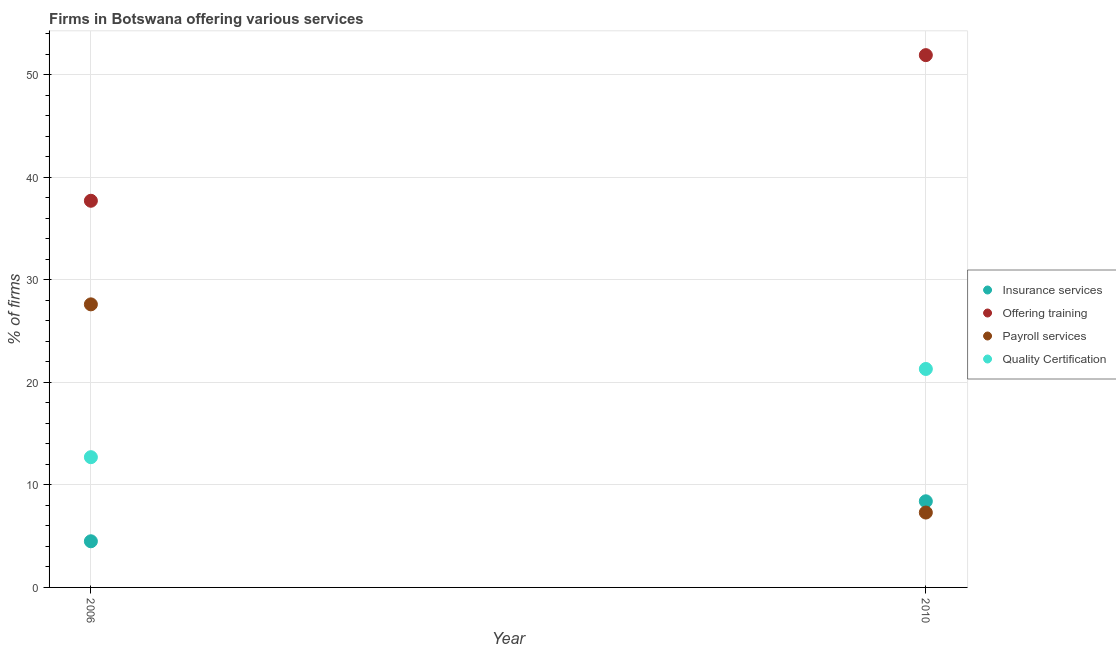How many different coloured dotlines are there?
Keep it short and to the point. 4. Is the number of dotlines equal to the number of legend labels?
Your answer should be compact. Yes. What is the percentage of firms offering insurance services in 2006?
Offer a very short reply. 4.5. Across all years, what is the maximum percentage of firms offering training?
Provide a succinct answer. 51.9. Across all years, what is the minimum percentage of firms offering training?
Your answer should be very brief. 37.7. In which year was the percentage of firms offering insurance services minimum?
Offer a very short reply. 2006. What is the total percentage of firms offering training in the graph?
Ensure brevity in your answer.  89.6. What is the difference between the percentage of firms offering training in 2006 and that in 2010?
Your answer should be very brief. -14.2. What is the difference between the percentage of firms offering quality certification in 2010 and the percentage of firms offering insurance services in 2006?
Your answer should be very brief. 16.8. What is the average percentage of firms offering payroll services per year?
Make the answer very short. 17.45. In the year 2006, what is the difference between the percentage of firms offering quality certification and percentage of firms offering insurance services?
Give a very brief answer. 8.2. In how many years, is the percentage of firms offering payroll services greater than 4 %?
Your response must be concise. 2. What is the ratio of the percentage of firms offering quality certification in 2006 to that in 2010?
Your answer should be compact. 0.6. In how many years, is the percentage of firms offering quality certification greater than the average percentage of firms offering quality certification taken over all years?
Provide a short and direct response. 1. Is it the case that in every year, the sum of the percentage of firms offering quality certification and percentage of firms offering training is greater than the sum of percentage of firms offering payroll services and percentage of firms offering insurance services?
Keep it short and to the point. Yes. Is it the case that in every year, the sum of the percentage of firms offering insurance services and percentage of firms offering training is greater than the percentage of firms offering payroll services?
Provide a succinct answer. Yes. Does the percentage of firms offering quality certification monotonically increase over the years?
Offer a terse response. Yes. Does the graph contain grids?
Your answer should be very brief. Yes. Where does the legend appear in the graph?
Offer a very short reply. Center right. How are the legend labels stacked?
Offer a terse response. Vertical. What is the title of the graph?
Your answer should be compact. Firms in Botswana offering various services . What is the label or title of the X-axis?
Your answer should be very brief. Year. What is the label or title of the Y-axis?
Offer a terse response. % of firms. What is the % of firms in Insurance services in 2006?
Provide a short and direct response. 4.5. What is the % of firms of Offering training in 2006?
Offer a terse response. 37.7. What is the % of firms in Payroll services in 2006?
Your answer should be compact. 27.6. What is the % of firms of Offering training in 2010?
Provide a short and direct response. 51.9. What is the % of firms in Payroll services in 2010?
Your answer should be compact. 7.3. What is the % of firms in Quality Certification in 2010?
Your answer should be very brief. 21.3. Across all years, what is the maximum % of firms of Offering training?
Your answer should be very brief. 51.9. Across all years, what is the maximum % of firms in Payroll services?
Give a very brief answer. 27.6. Across all years, what is the maximum % of firms in Quality Certification?
Give a very brief answer. 21.3. Across all years, what is the minimum % of firms in Insurance services?
Offer a very short reply. 4.5. Across all years, what is the minimum % of firms in Offering training?
Offer a very short reply. 37.7. Across all years, what is the minimum % of firms of Payroll services?
Keep it short and to the point. 7.3. Across all years, what is the minimum % of firms of Quality Certification?
Keep it short and to the point. 12.7. What is the total % of firms of Offering training in the graph?
Your response must be concise. 89.6. What is the total % of firms of Payroll services in the graph?
Provide a short and direct response. 34.9. What is the difference between the % of firms of Payroll services in 2006 and that in 2010?
Provide a short and direct response. 20.3. What is the difference between the % of firms of Insurance services in 2006 and the % of firms of Offering training in 2010?
Your answer should be very brief. -47.4. What is the difference between the % of firms in Insurance services in 2006 and the % of firms in Quality Certification in 2010?
Keep it short and to the point. -16.8. What is the difference between the % of firms in Offering training in 2006 and the % of firms in Payroll services in 2010?
Ensure brevity in your answer.  30.4. What is the difference between the % of firms in Offering training in 2006 and the % of firms in Quality Certification in 2010?
Keep it short and to the point. 16.4. What is the difference between the % of firms of Payroll services in 2006 and the % of firms of Quality Certification in 2010?
Keep it short and to the point. 6.3. What is the average % of firms of Insurance services per year?
Provide a short and direct response. 6.45. What is the average % of firms in Offering training per year?
Your answer should be compact. 44.8. What is the average % of firms of Payroll services per year?
Provide a succinct answer. 17.45. What is the average % of firms of Quality Certification per year?
Your answer should be compact. 17. In the year 2006, what is the difference between the % of firms of Insurance services and % of firms of Offering training?
Provide a succinct answer. -33.2. In the year 2006, what is the difference between the % of firms in Insurance services and % of firms in Payroll services?
Ensure brevity in your answer.  -23.1. In the year 2006, what is the difference between the % of firms in Insurance services and % of firms in Quality Certification?
Provide a succinct answer. -8.2. In the year 2006, what is the difference between the % of firms in Offering training and % of firms in Payroll services?
Provide a succinct answer. 10.1. In the year 2006, what is the difference between the % of firms in Offering training and % of firms in Quality Certification?
Provide a short and direct response. 25. In the year 2010, what is the difference between the % of firms in Insurance services and % of firms in Offering training?
Offer a terse response. -43.5. In the year 2010, what is the difference between the % of firms of Insurance services and % of firms of Quality Certification?
Provide a short and direct response. -12.9. In the year 2010, what is the difference between the % of firms in Offering training and % of firms in Payroll services?
Provide a short and direct response. 44.6. In the year 2010, what is the difference between the % of firms of Offering training and % of firms of Quality Certification?
Offer a very short reply. 30.6. What is the ratio of the % of firms in Insurance services in 2006 to that in 2010?
Your answer should be very brief. 0.54. What is the ratio of the % of firms of Offering training in 2006 to that in 2010?
Offer a terse response. 0.73. What is the ratio of the % of firms in Payroll services in 2006 to that in 2010?
Give a very brief answer. 3.78. What is the ratio of the % of firms of Quality Certification in 2006 to that in 2010?
Provide a short and direct response. 0.6. What is the difference between the highest and the second highest % of firms of Insurance services?
Ensure brevity in your answer.  3.9. What is the difference between the highest and the second highest % of firms in Offering training?
Make the answer very short. 14.2. What is the difference between the highest and the second highest % of firms in Payroll services?
Offer a very short reply. 20.3. What is the difference between the highest and the lowest % of firms in Payroll services?
Offer a terse response. 20.3. 